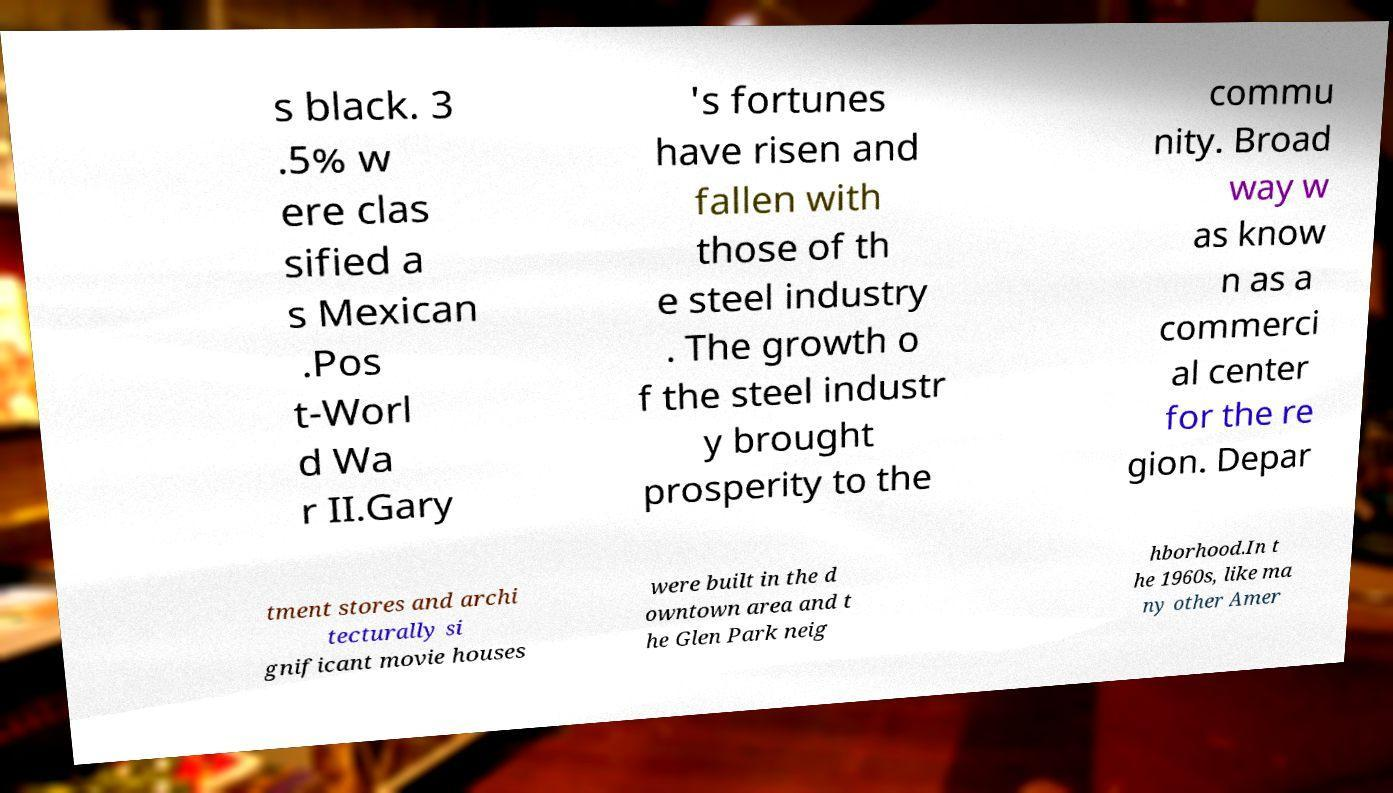Could you extract and type out the text from this image? s black. 3 .5% w ere clas sified a s Mexican .Pos t-Worl d Wa r II.Gary 's fortunes have risen and fallen with those of th e steel industry . The growth o f the steel industr y brought prosperity to the commu nity. Broad way w as know n as a commerci al center for the re gion. Depar tment stores and archi tecturally si gnificant movie houses were built in the d owntown area and t he Glen Park neig hborhood.In t he 1960s, like ma ny other Amer 